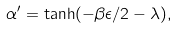Convert formula to latex. <formula><loc_0><loc_0><loc_500><loc_500>\alpha ^ { \prime } = \tanh ( - \beta \epsilon / 2 - \lambda ) ,</formula> 